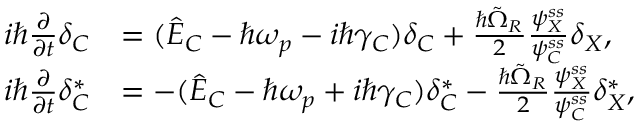Convert formula to latex. <formula><loc_0><loc_0><loc_500><loc_500>\begin{array} { r l } { i \hbar { } \partial } { \partial t } \delta _ { C } } & { = ( \hat { E } _ { C } - \hbar { \omega } _ { p } - i \hbar { \gamma } _ { C } ) \delta _ { C } + \frac { \hbar { \tilde } { \Omega } _ { R } } { 2 } \frac { \psi _ { X } ^ { s s } } { \psi _ { C } ^ { s s } } \delta _ { X } , } \\ { i \hbar { } \partial } { \partial t } \delta _ { C } ^ { * } } & { = - ( \hat { E } _ { C } - \hbar { \omega } _ { p } + i \hbar { \gamma } _ { C } ) \delta _ { C } ^ { * } - \frac { \hbar { \tilde } { \Omega } _ { R } } { 2 } \frac { \psi _ { X } ^ { s s } } { \psi _ { C } ^ { s s } } \delta _ { X } ^ { * } , } \end{array}</formula> 